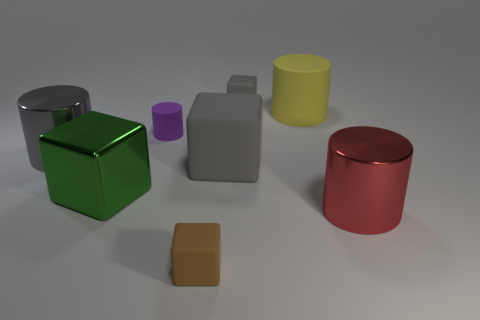What is the shape of the gray object that is in front of the shiny cylinder that is behind the shiny thing right of the yellow object?
Ensure brevity in your answer.  Cube. Is the number of things behind the gray metallic object greater than the number of big gray metallic cylinders?
Make the answer very short. Yes. Does the small brown matte object have the same shape as the gray rubber thing that is to the left of the small gray cube?
Your answer should be very brief. Yes. What is the shape of the big shiny thing that is the same color as the big rubber cube?
Your response must be concise. Cylinder. What number of small brown blocks are in front of the rubber block that is in front of the shiny thing that is in front of the green shiny object?
Your answer should be very brief. 0. What is the color of the rubber cube that is the same size as the green object?
Provide a succinct answer. Gray. How big is the metal cylinder that is on the right side of the gray rubber block behind the purple rubber thing?
Your response must be concise. Large. There is a matte object that is the same color as the large matte cube; what is its size?
Provide a short and direct response. Small. What number of other objects are the same size as the yellow thing?
Ensure brevity in your answer.  4. How many big brown matte balls are there?
Provide a short and direct response. 0. 